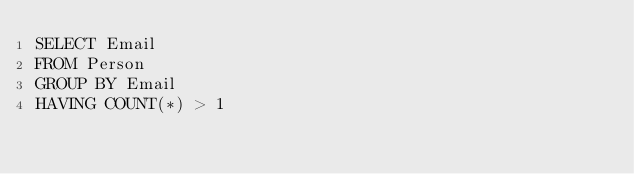Convert code to text. <code><loc_0><loc_0><loc_500><loc_500><_SQL_>SELECT Email
FROM Person
GROUP BY Email
HAVING COUNT(*) > 1
</code> 